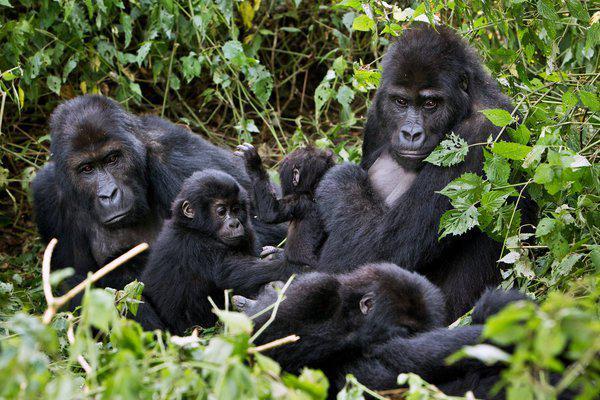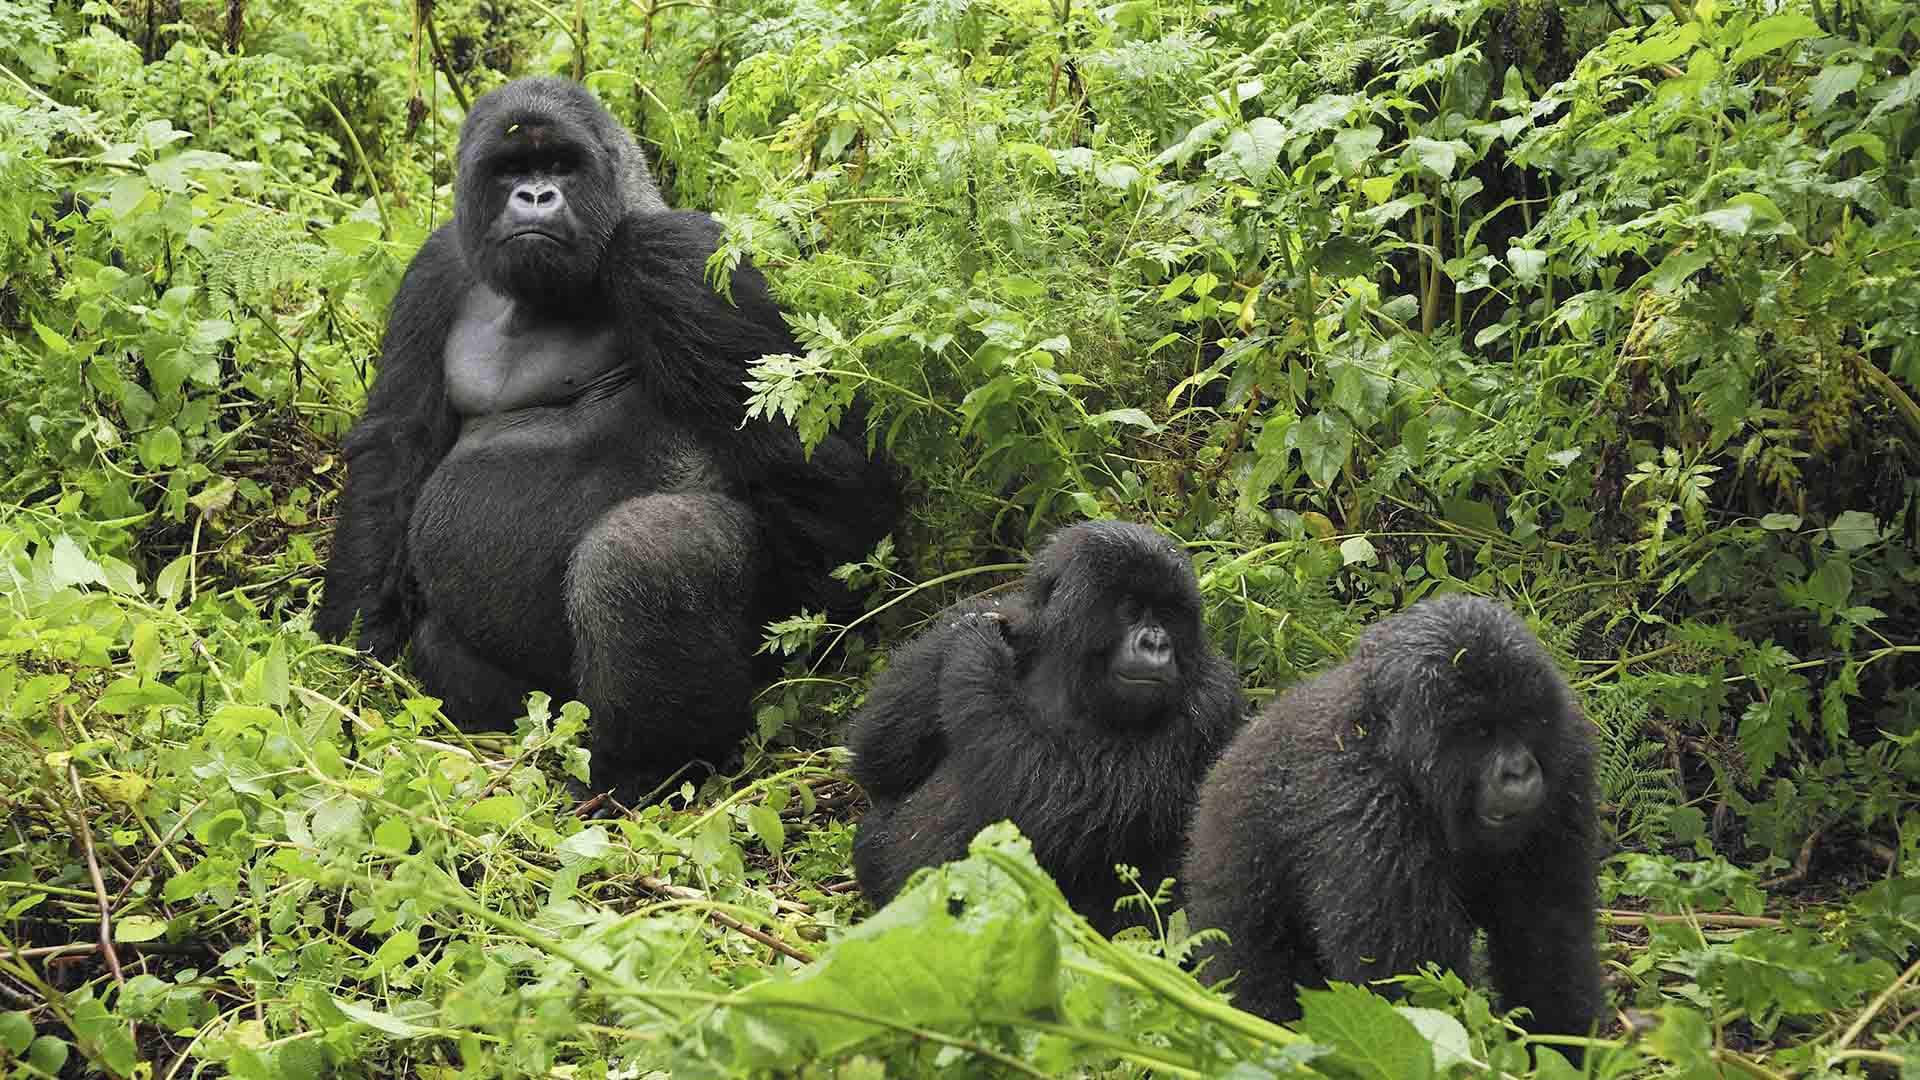The first image is the image on the left, the second image is the image on the right. For the images shown, is this caption "All of the images have two generations of apes." true? Answer yes or no. Yes. The first image is the image on the left, the second image is the image on the right. Given the left and right images, does the statement "The small gorilla is on top of the larger one in the image on the left." hold true? Answer yes or no. No. 